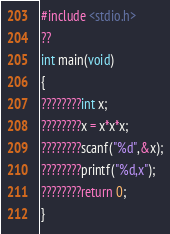Convert code to text. <code><loc_0><loc_0><loc_500><loc_500><_C_>#include <stdio.h>
??
int main(void)
{
????????int x;
????????x = x*x*x;
????????scanf("%d",&x);
????????printf("%d,x");
????????return 0;
}</code> 